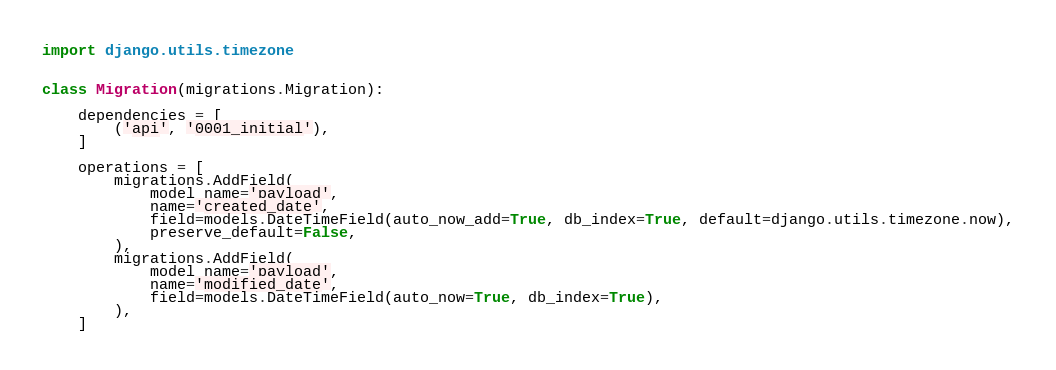Convert code to text. <code><loc_0><loc_0><loc_500><loc_500><_Python_>import django.utils.timezone


class Migration(migrations.Migration):

    dependencies = [
        ('api', '0001_initial'),
    ]

    operations = [
        migrations.AddField(
            model_name='payload',
            name='created_date',
            field=models.DateTimeField(auto_now_add=True, db_index=True, default=django.utils.timezone.now),
            preserve_default=False,
        ),
        migrations.AddField(
            model_name='payload',
            name='modified_date',
            field=models.DateTimeField(auto_now=True, db_index=True),
        ),
    ]
</code> 